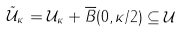Convert formula to latex. <formula><loc_0><loc_0><loc_500><loc_500>\tilde { \mathcal { U } } _ { \kappa } = \mathcal { U } _ { \kappa } + \overline { B } ( 0 , \kappa / 2 ) \subseteq \mathcal { U }</formula> 